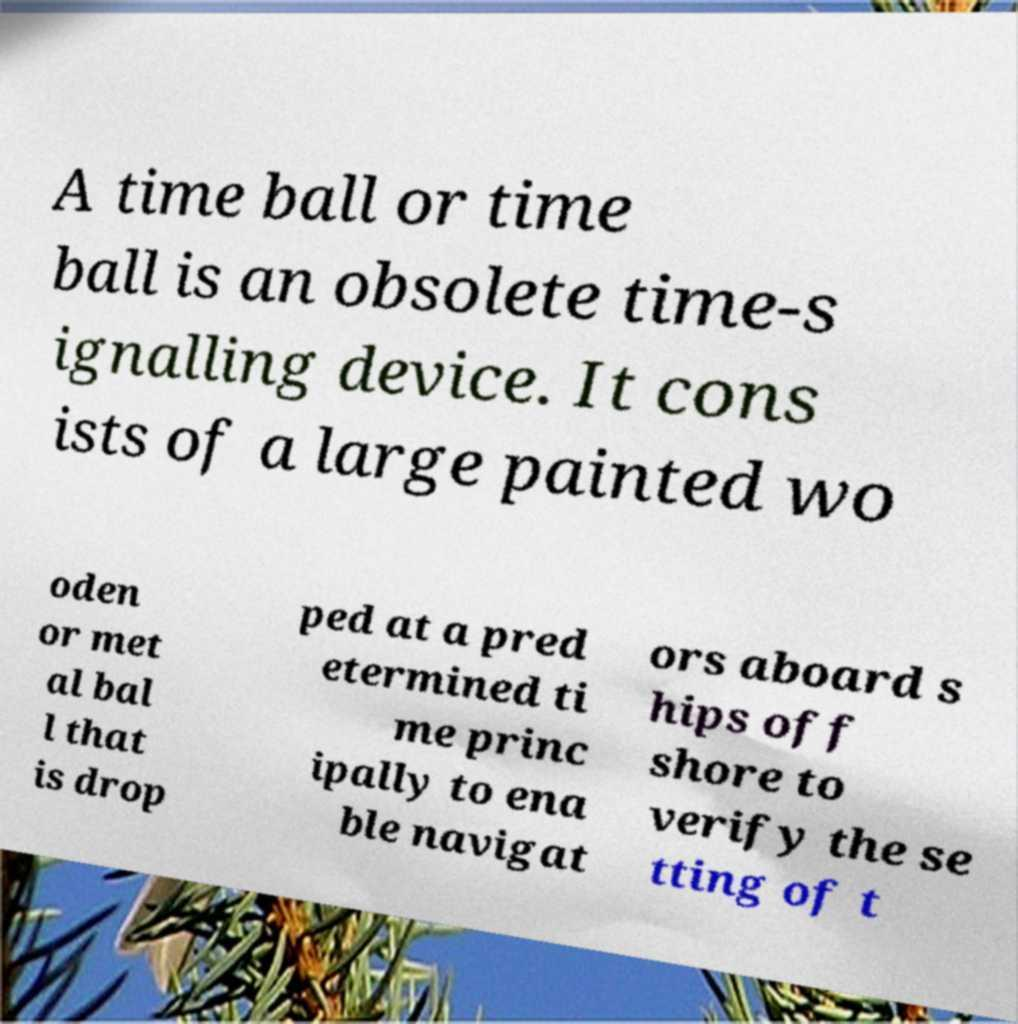For documentation purposes, I need the text within this image transcribed. Could you provide that? A time ball or time ball is an obsolete time-s ignalling device. It cons ists of a large painted wo oden or met al bal l that is drop ped at a pred etermined ti me princ ipally to ena ble navigat ors aboard s hips off shore to verify the se tting of t 